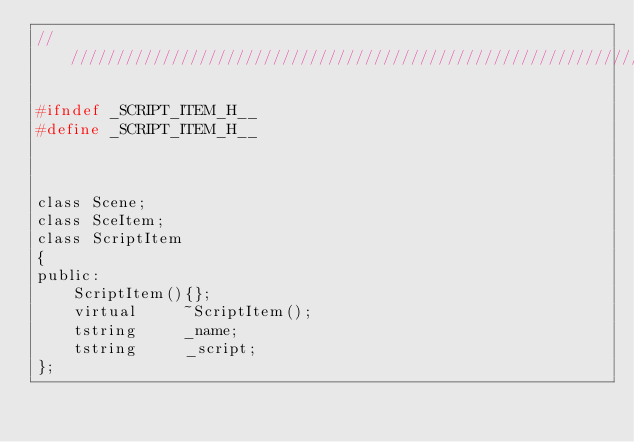Convert code to text. <code><loc_0><loc_0><loc_500><loc_500><_C_>//////////////////////////////////////////////////////////////////////

#ifndef _SCRIPT_ITEM_H__
#define _SCRIPT_ITEM_H__



class Scene;
class SceItem;
class ScriptItem 
{
public:
	ScriptItem(){};
	virtual		~ScriptItem();
    tstring     _name;
	tstring		_script;        
};
</code> 